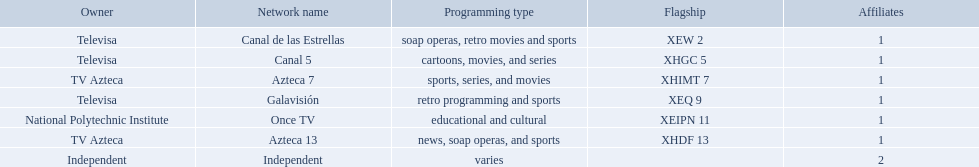What stations show sports? Soap operas, retro movies and sports, retro programming and sports, news, soap operas, and sports. What of these is not affiliated with televisa? Azteca 7. Who are the owners of the stations listed here? Televisa, Televisa, TV Azteca, Televisa, National Polytechnic Institute, TV Azteca, Independent. What is the one station owned by national polytechnic institute? Once TV. 